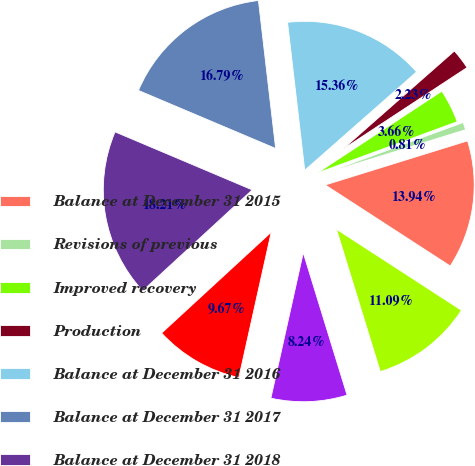Convert chart to OTSL. <chart><loc_0><loc_0><loc_500><loc_500><pie_chart><fcel>Balance at December 31 2015<fcel>Revisions of previous<fcel>Improved recovery<fcel>Production<fcel>Balance at December 31 2016<fcel>Balance at December 31 2017<fcel>Balance at December 31 2018<fcel>December 31 2015<fcel>December 31 2016<fcel>December 31 2017<nl><fcel>13.94%<fcel>0.81%<fcel>3.66%<fcel>2.23%<fcel>15.36%<fcel>16.79%<fcel>18.21%<fcel>9.67%<fcel>8.24%<fcel>11.09%<nl></chart> 